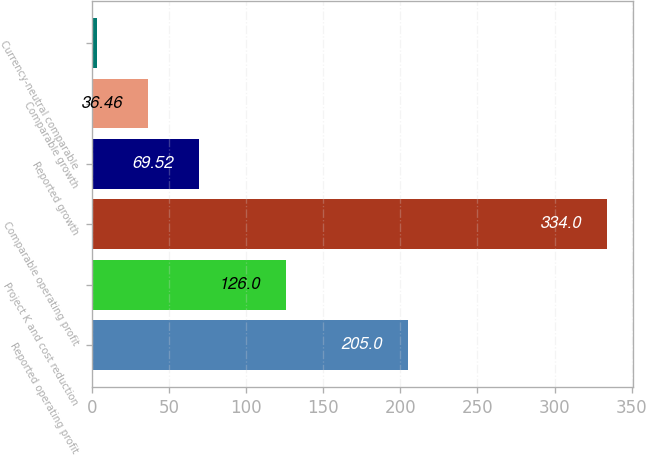<chart> <loc_0><loc_0><loc_500><loc_500><bar_chart><fcel>Reported operating profit<fcel>Project K and cost reduction<fcel>Comparable operating profit<fcel>Reported growth<fcel>Comparable growth<fcel>Currency-neutral comparable<nl><fcel>205<fcel>126<fcel>334<fcel>69.52<fcel>36.46<fcel>3.4<nl></chart> 